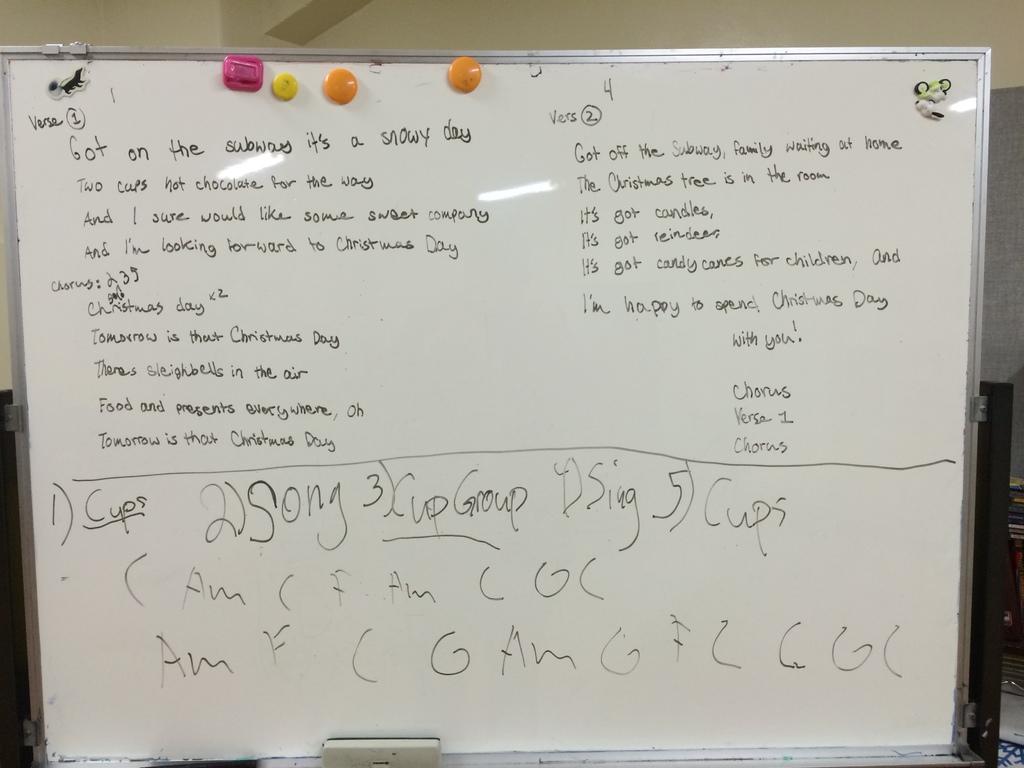How many song?
Provide a succinct answer. 2. What is the verse number?
Your response must be concise. 1. 